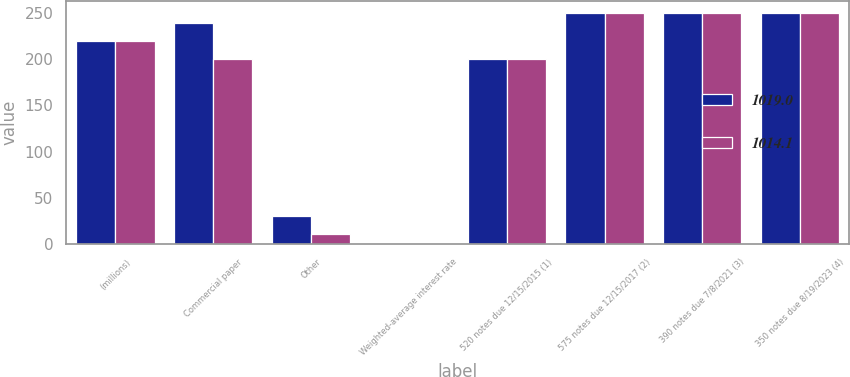<chart> <loc_0><loc_0><loc_500><loc_500><stacked_bar_chart><ecel><fcel>(millions)<fcel>Commercial paper<fcel>Other<fcel>Weighted-average interest rate<fcel>520 notes due 12/15/2015 (1)<fcel>575 notes due 12/15/2017 (2)<fcel>390 notes due 7/8/2021 (3)<fcel>350 notes due 8/19/2023 (4)<nl><fcel>1019<fcel>219.85<fcel>239.4<fcel>30.2<fcel>1.3<fcel>200<fcel>250<fcel>250<fcel>250<nl><fcel>1014.1<fcel>219.85<fcel>200.3<fcel>11.3<fcel>0.7<fcel>200<fcel>250<fcel>250<fcel>250<nl></chart> 